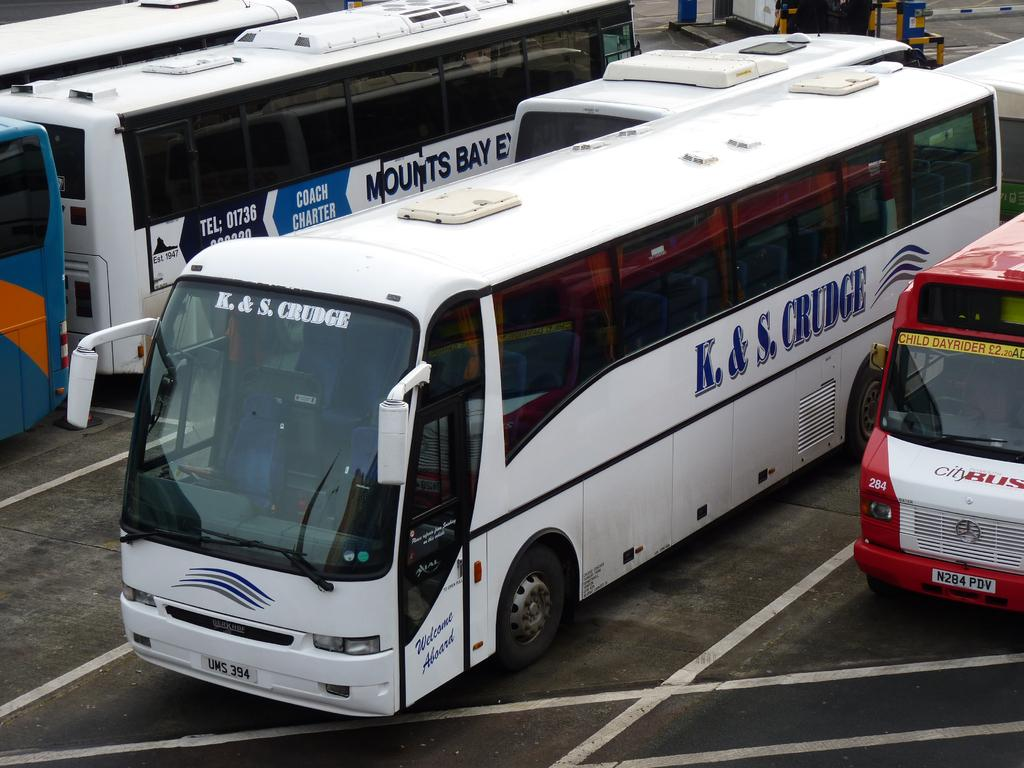Provide a one-sentence caption for the provided image. The white bus in the middle is from K&S. Krudge. 